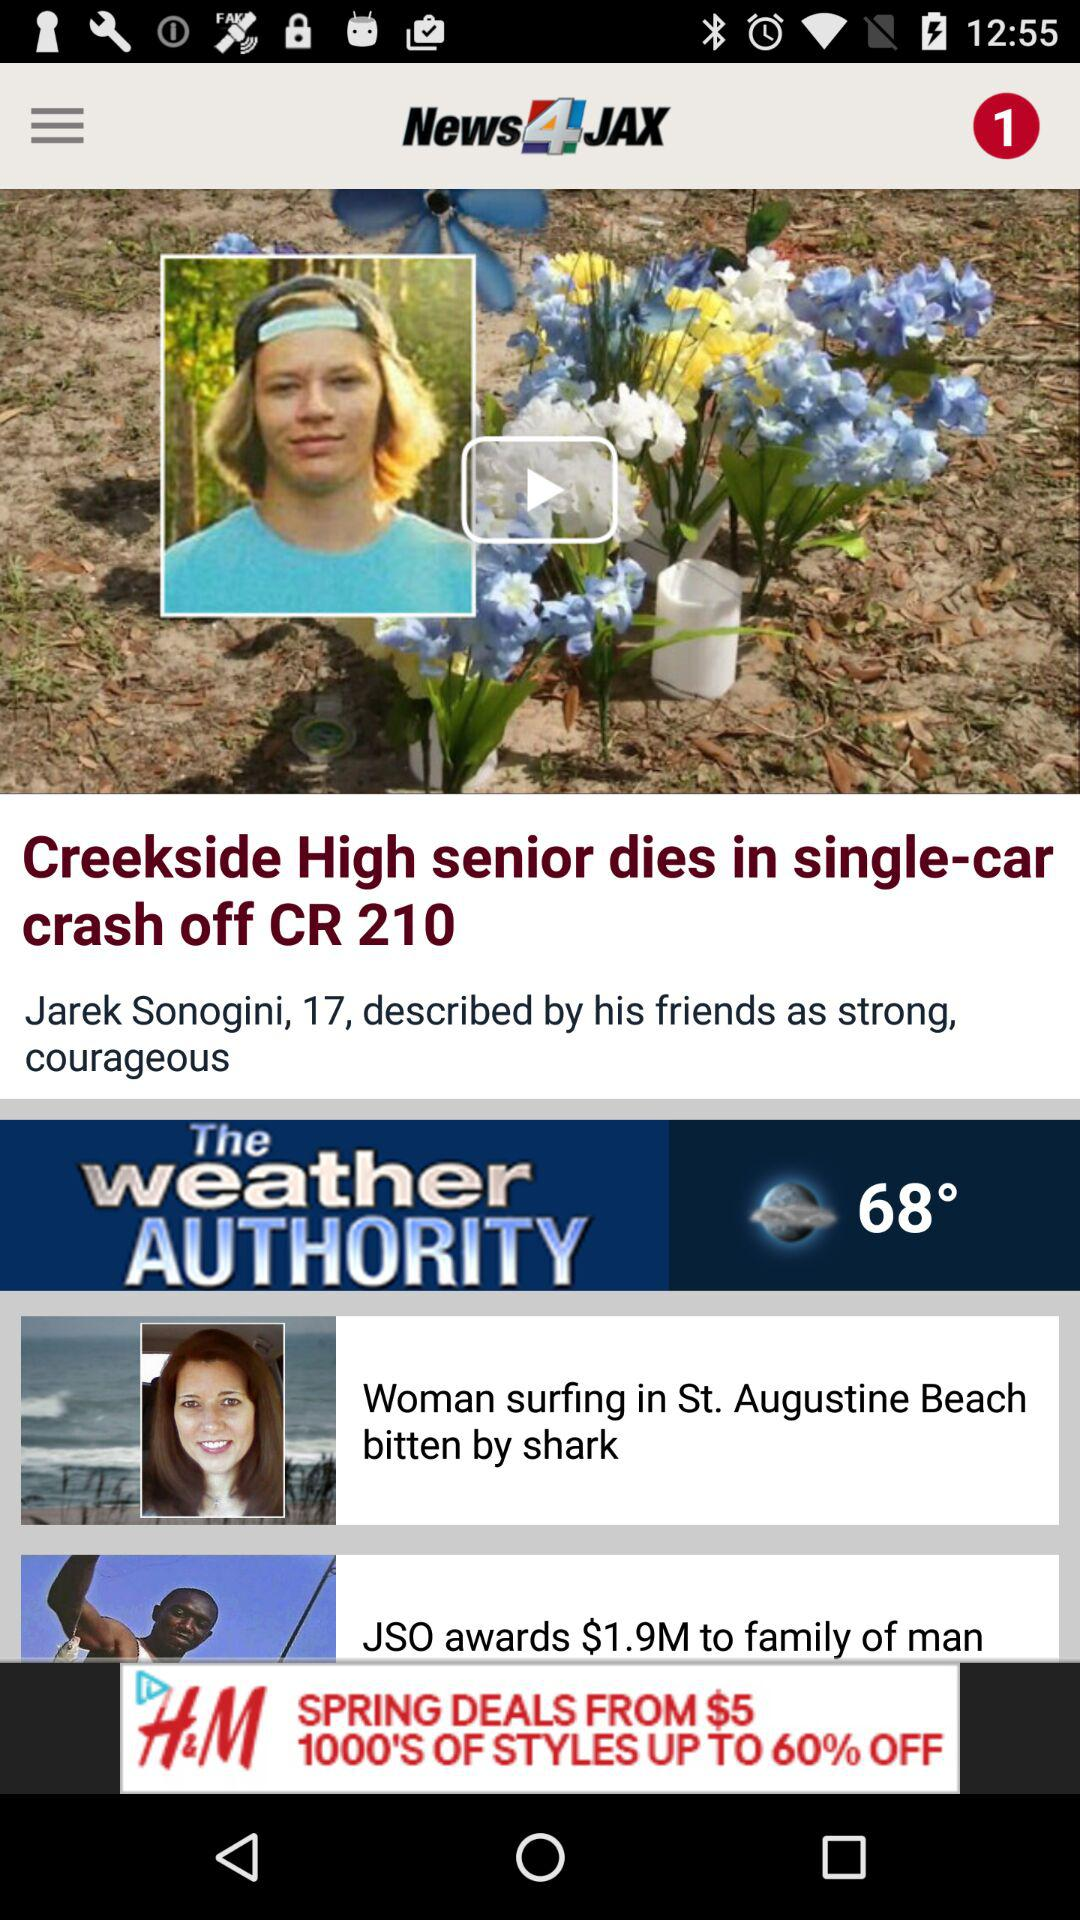What is the headline?
When the provided information is insufficient, respond with <no answer>. <no answer> 